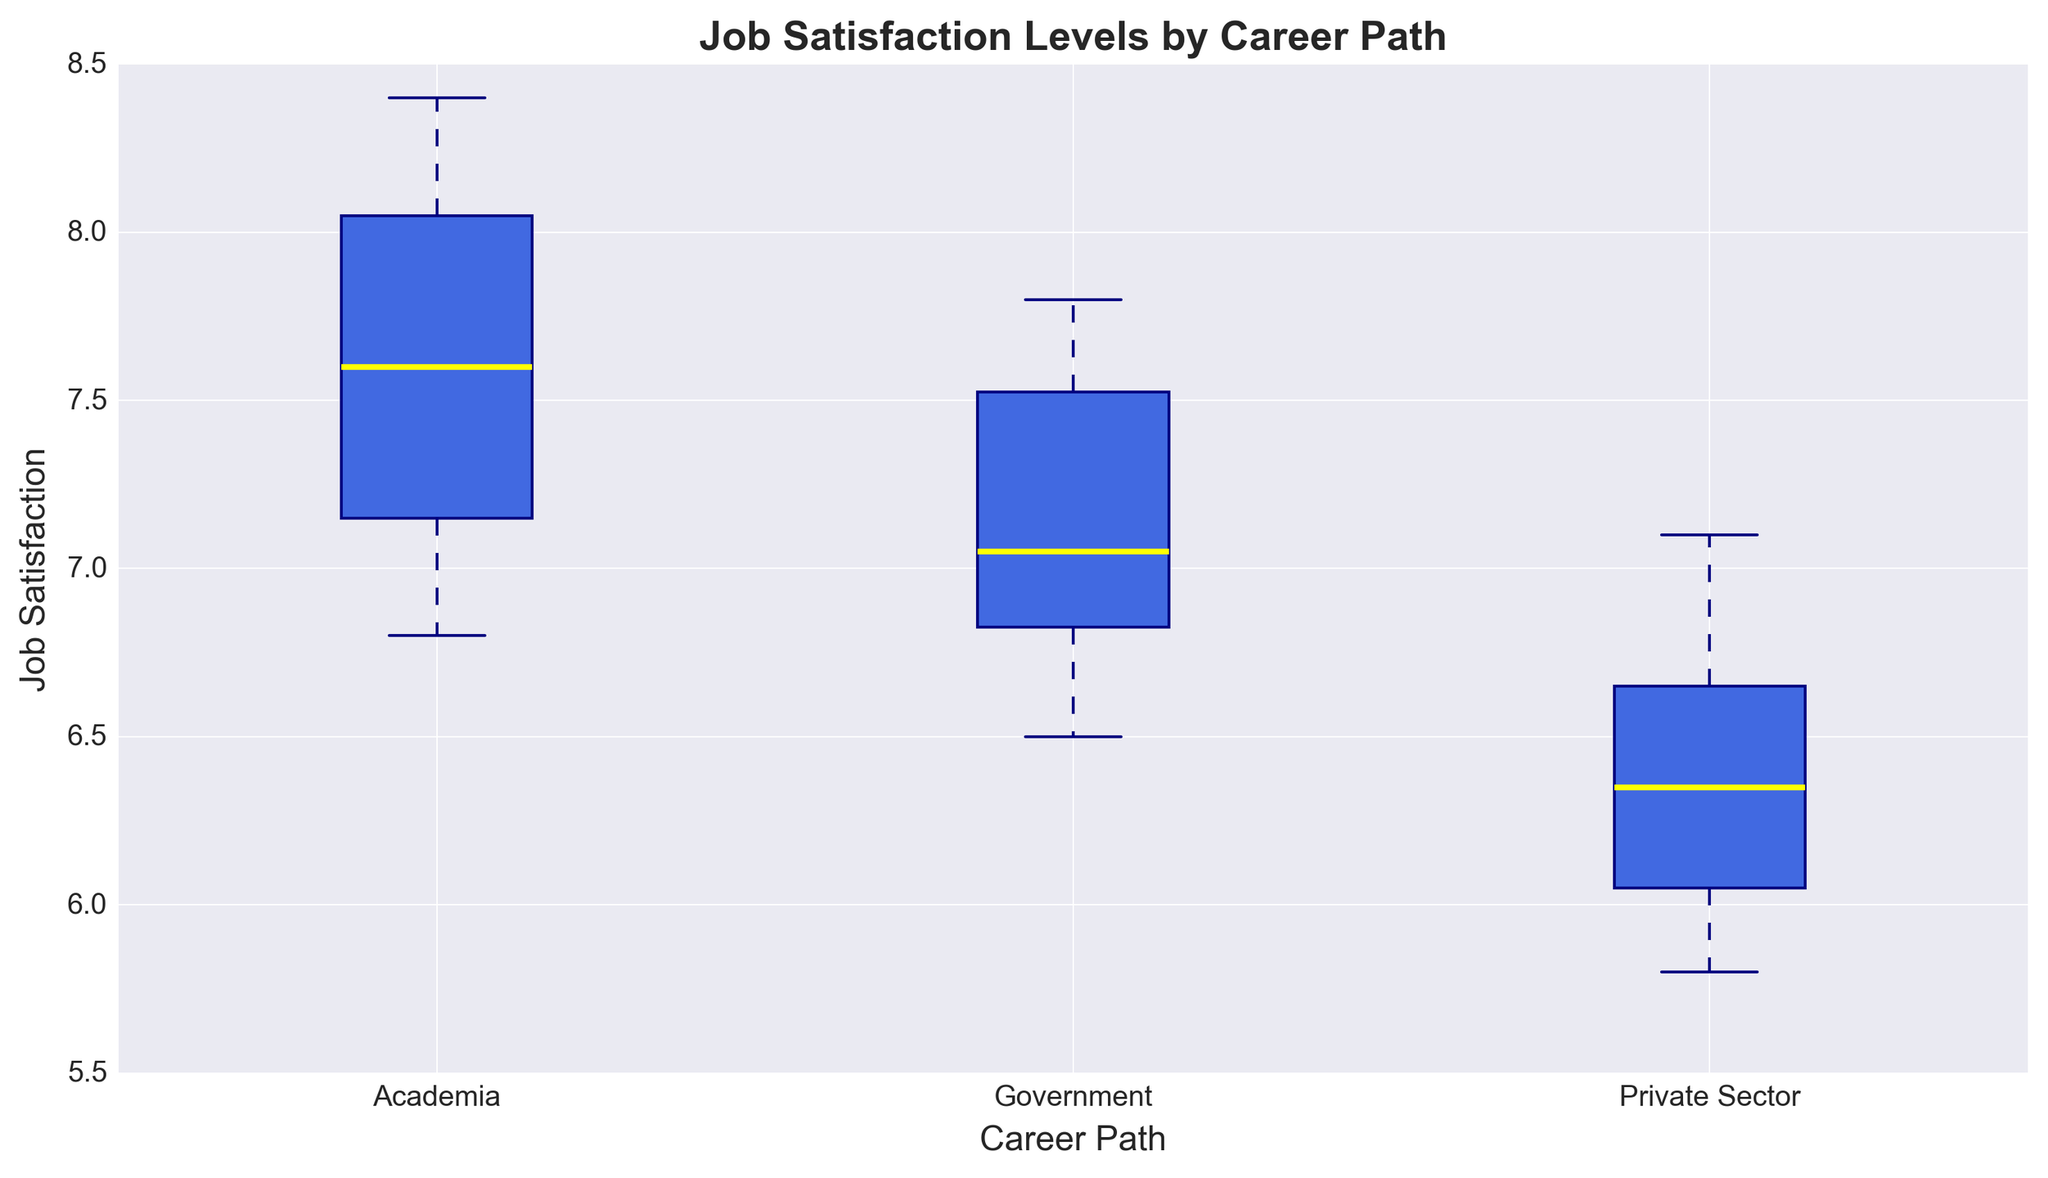Which career path has the highest median job satisfaction? To find the career path with the highest median job satisfaction, look at the middle line inside the box of each box plot. The highest median line, indicated by the yellow line in the figure, belongs to Academia.
Answer: Academia Which career path has the lowest median job satisfaction? Identify the box plot with the lowest median line. In this case, the median line is indicated by the yellow line and the lowest one is in the Private Sector box plot.
Answer: Private Sector What is the range of job satisfaction for the Government sector? Determine the difference between the maximum and minimum values represented by the top and bottom of the whiskers for the Government sector. The maximum value is 7.8, and the minimum value is 6.5, so the range is 7.8 - 6.5 = 1.3.
Answer: 1.3 Which career path has the most outliers in job satisfaction levels? Look for the box plots that have dots outside the whiskers. The Private Sector has the most outliers, as indicated by multiple red dots.
Answer: Private Sector How does the interquartile range (IQR) of job satisfaction compare between Academia and Private Sector careers? The IQR is the range between the first quartile (Q1) and the third quartile (Q3) in each box plot. Visual comparison shows that Academia has a smaller IQR (tighter box) compared to the Private Sector, which has a larger spread (wider box).
Answer: Academia has a smaller IQR than Private Sector Are any of the career paths' job satisfaction levels symmetrically distributed? A symmetrically distributed box plot has a median line approximately in the center of the box and whiskers of roughly equal length. Both Academia and Government career paths show relatively symmetrical distributions compared to Private Sector.
Answer: Academia, Government Which career path shows the widest variability in job satisfaction levels? The career path with the widest variability is indicated by the widest range from the bottom to top whisker. The Private Sector, with the maximum spread between whiskers and a larger spread within the box (higher IQR), shows the widest variability.
Answer: Private Sector If we combine the job satisfaction scores for all the career paths, what is the median job satisfaction level? To find the median of all combined data, we list all job satisfaction scores and find the middle value. However, simply noting that the combined box plots medians center around 7 indicates an approximate combined median close to 7.
Answer: Around 7 